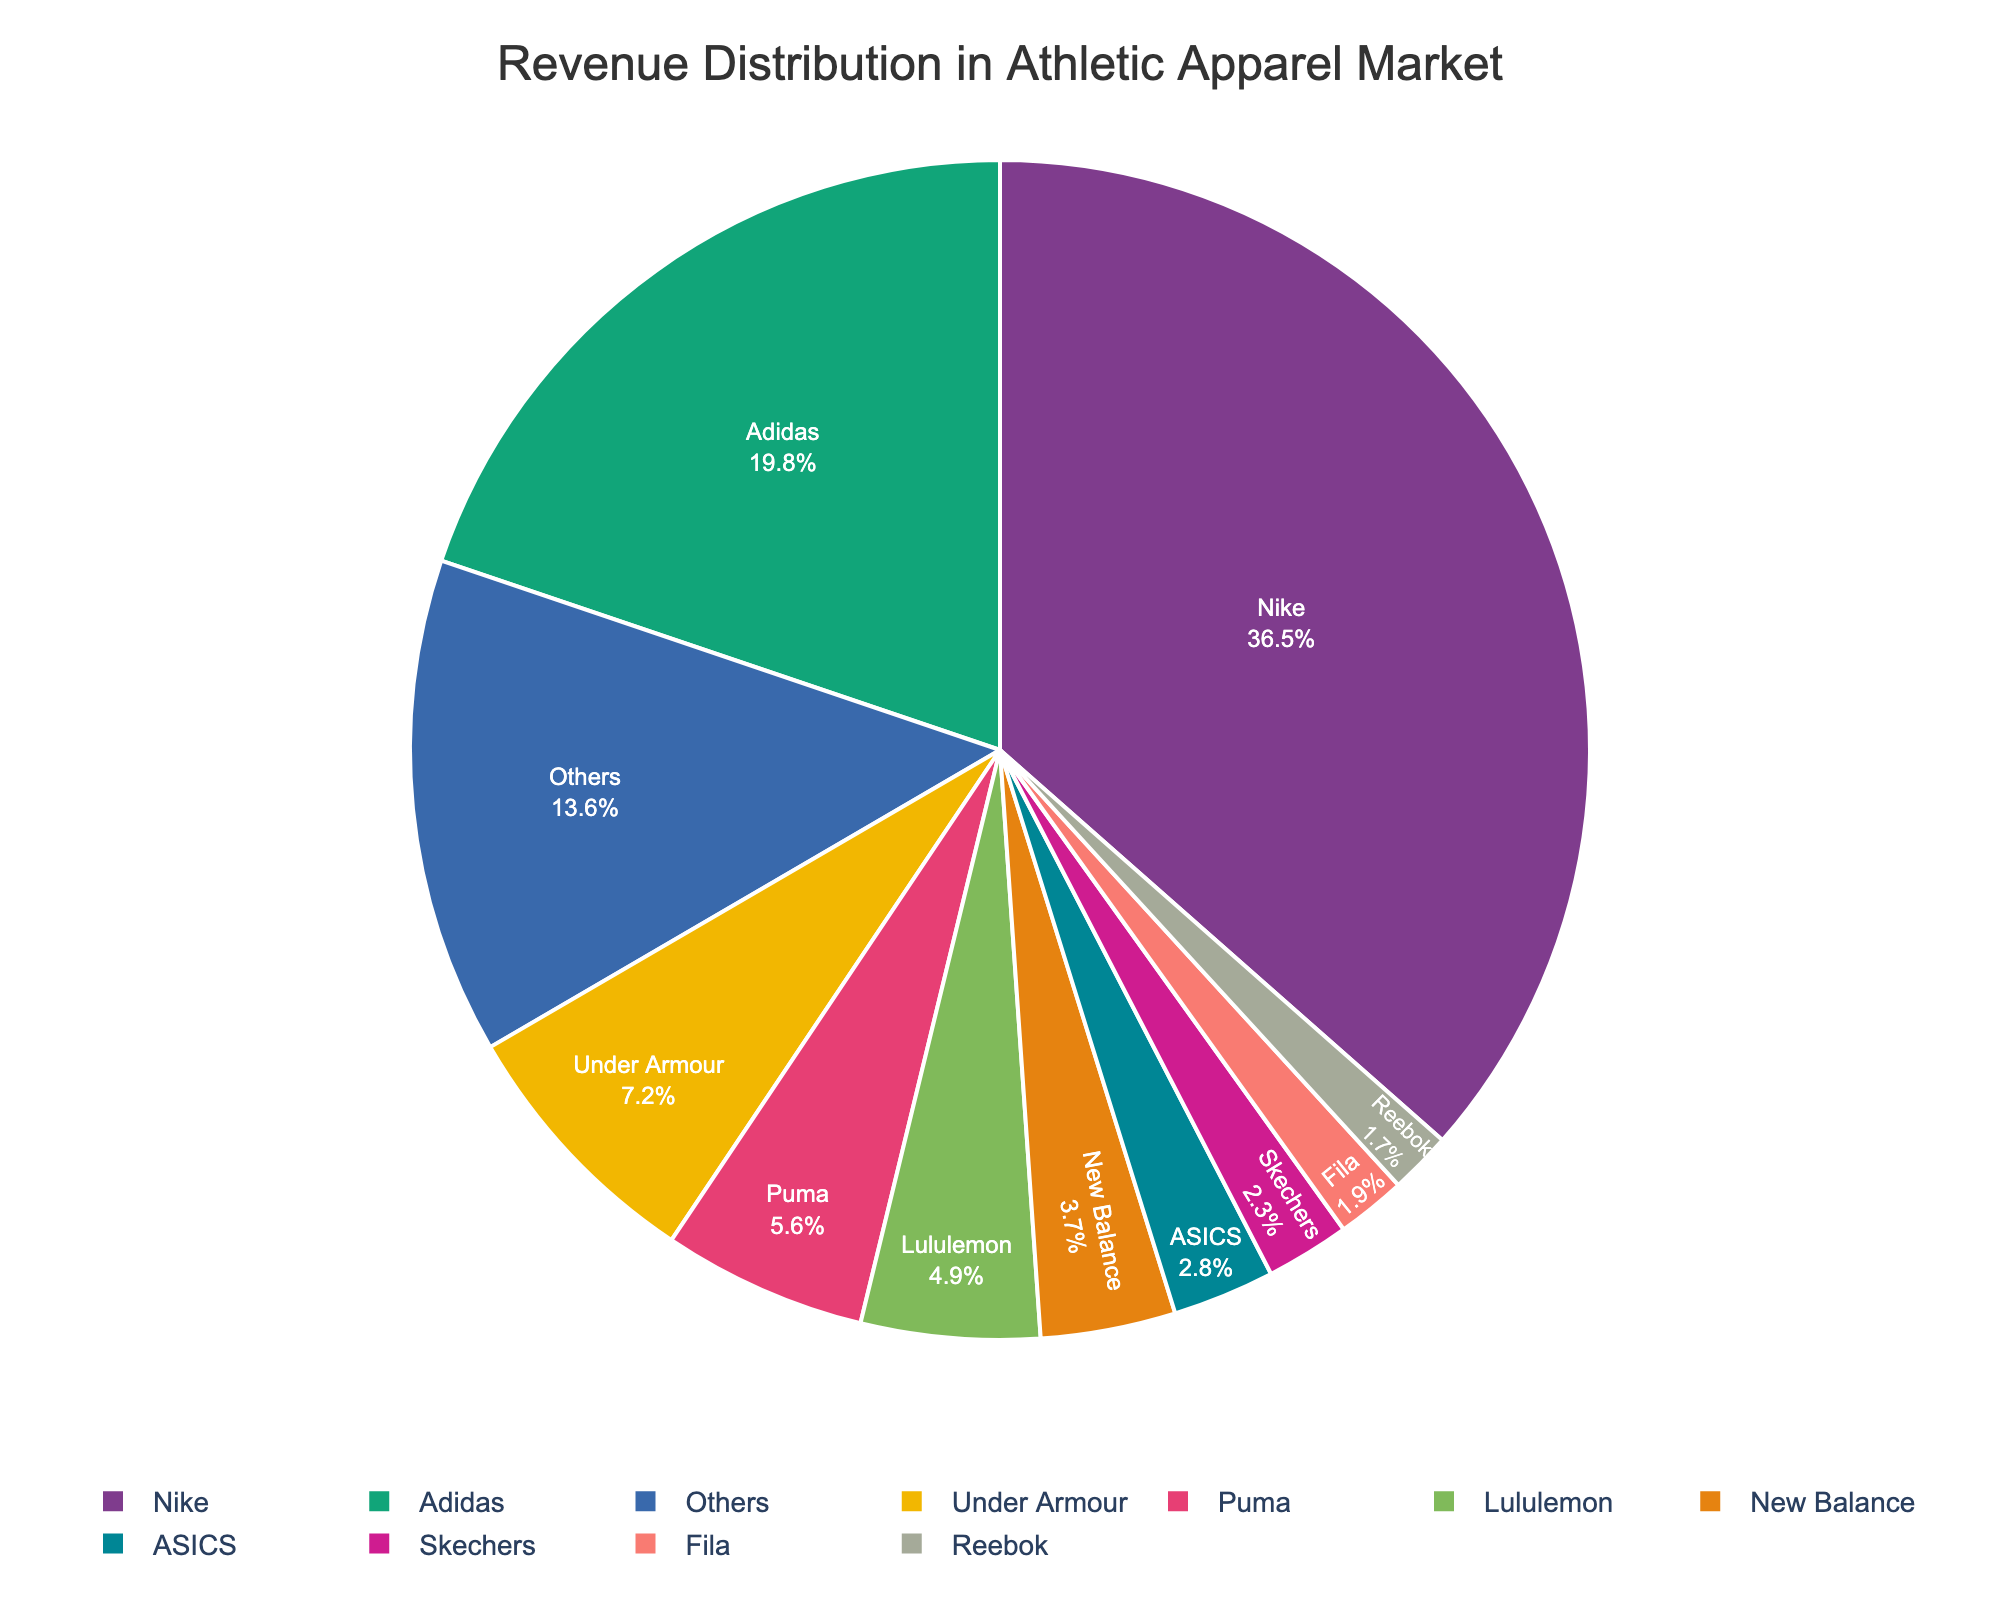Which brand has the largest market share? The brand with the largest market share is the one occupying the largest slice in the pie chart. The chart shows that Nike has the largest slice.
Answer: Nike Which two brands combined have a market share close to 40%? Adding the market shares of Nike (36.5%) and Adidas (19.8%) gives a total of 56.3%, which is much higher than 40%. Adding Adidas (19.8%) and Under Armour (7.2%) gives 27%, which is less than 40%. Adding Nike (36.5%) and Others (13.6%) gives a total of 50.1%, still higher than 40%. The closest combination is Nike (36.5%) and New Balance (3.7%), which gives a total of 40.2%.
Answer: Nike and New Balance How does Adidas' market share compare to Under Armour's? To compare their market shares, we look at both their sections in the pie chart. Adidas has a share of 19.8%, while Under Armour has 7.2%. Therefore, Adidas' market share is larger.
Answer: Adidas has a larger market share What is the combined market share of Puma, Lululemon, and New Balance? Summing the market shares of Puma (5.6%), Lululemon (4.9%), and New Balance (3.7%) gives a total of 5.6 + 4.9 + 3.7 = 14.2%.
Answer: 14.2% Which brand has a market share closest to 5%? We look at the percentages and see which one is closest to 5%. Puma is 5.6%, Lululemon is 4.9%. Lululemon is closer to 5%.
Answer: Lululemon How many brands have a market share less than 5%? We count the slices that represent less than 5% each: Lululemon (4.9%), New Balance (3.7%), ASICS (2.8%), Skechers (2.3%), Fila (1.9%), Reebok (1.7%), and Others (13.6%) but "Others" is not a single brand. The total is 6.
Answer: 6 What is the market share difference between Nike and the combined share of Puma and Lululemon? Nike has 36.5%, while Puma and Lululemon together have 5.6 + 4.9 = 10.5%. The difference is 36.5 - 10.5 = 26%.
Answer: 26% Is Under Armour's market share greater than the combined market share of Reebok and ASICS? Under Armour's share is 7.2%, while Reebok (1.7%) and ASICS (2.8%) together is 1.7 + 2.8 = 4.5%. Hence, Under Armour's market share is indeed greater.
Answer: Yes What is the market share of the smallest brand? The smallest share on the pie chart belongs to Reebok with 1.7%.
Answer: 1.7% 